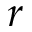Convert formula to latex. <formula><loc_0><loc_0><loc_500><loc_500>r</formula> 